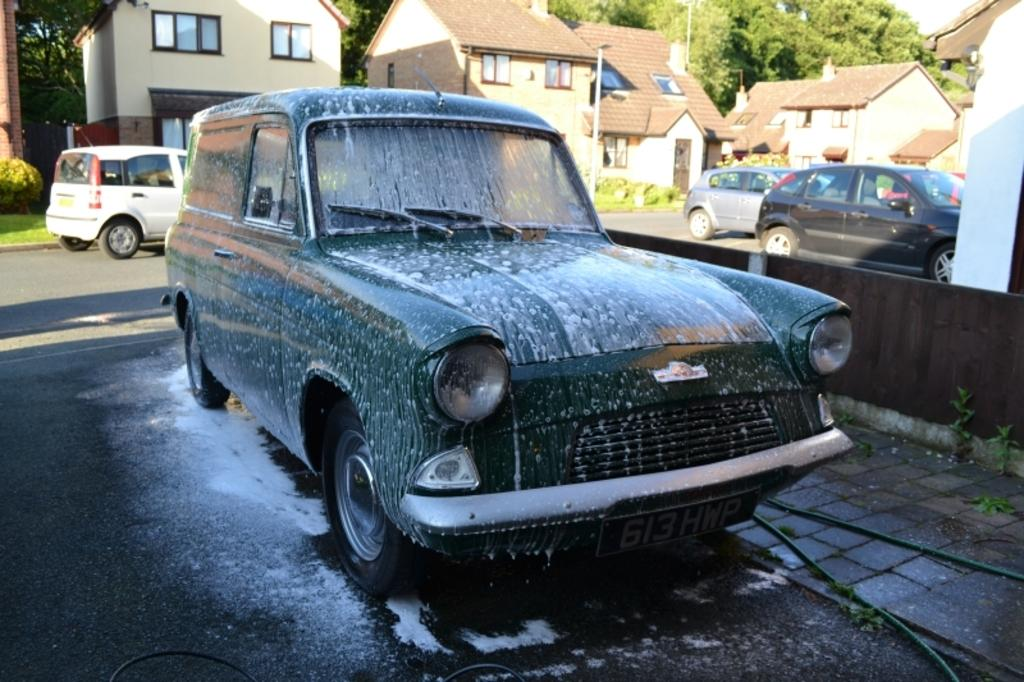What type of vehicle is in the foreground of the image? There is a green color car in the foreground of the image. What is happening to the car in the image? The car is getting washed. What can be seen in the background of the image? There are cars, buildings, poles, and trees in the background of the image. Can you describe the top right corner of the image? There is a wall in the top right corner of the image. What type of sea creature can be seen swimming in the image? There is no sea creature present in the image; it features a car getting washed in the foreground and various elements in the background. What kind of music is playing in the background of the image? There is no music present in the image; it is a still photograph of a car getting washed and the surrounding environment. 